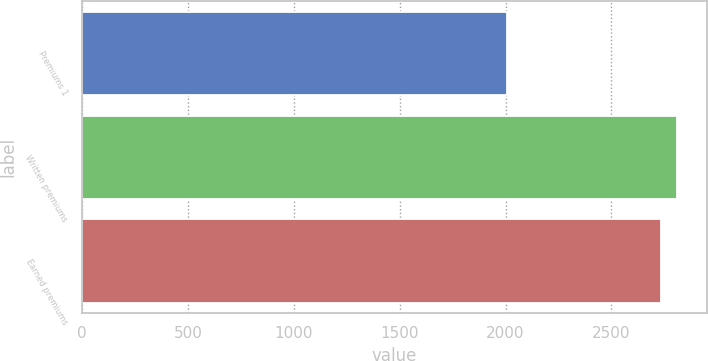Convert chart to OTSL. <chart><loc_0><loc_0><loc_500><loc_500><bar_chart><fcel>Premiums 1<fcel>Written premiums<fcel>Earned premiums<nl><fcel>2007<fcel>2810<fcel>2736<nl></chart> 